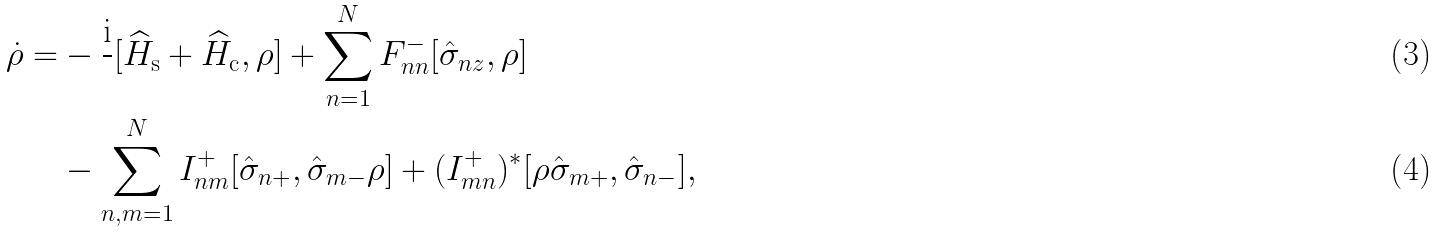<formula> <loc_0><loc_0><loc_500><loc_500>\dot { \rho } = & - \frac { \text {i} } { } [ \widehat { H } _ { \text {s} } + \widehat { H } _ { \text {c} } , \rho ] + \sum _ { n = 1 } ^ { N } F ^ { - } _ { n n } [ \hat { \sigma } _ { n z } , \rho ] \\ & - \sum _ { n , m = 1 } ^ { N } I _ { n m } ^ { + } [ \hat { \sigma } _ { n + } , \hat { \sigma } _ { m - } \rho ] + ( I _ { m n } ^ { + } ) ^ { * } [ \rho \hat { \sigma } _ { m + } , \hat { \sigma } _ { n - } ] ,</formula> 